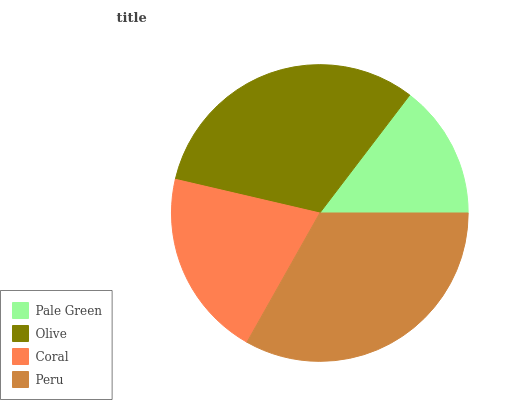Is Pale Green the minimum?
Answer yes or no. Yes. Is Peru the maximum?
Answer yes or no. Yes. Is Olive the minimum?
Answer yes or no. No. Is Olive the maximum?
Answer yes or no. No. Is Olive greater than Pale Green?
Answer yes or no. Yes. Is Pale Green less than Olive?
Answer yes or no. Yes. Is Pale Green greater than Olive?
Answer yes or no. No. Is Olive less than Pale Green?
Answer yes or no. No. Is Olive the high median?
Answer yes or no. Yes. Is Coral the low median?
Answer yes or no. Yes. Is Peru the high median?
Answer yes or no. No. Is Pale Green the low median?
Answer yes or no. No. 